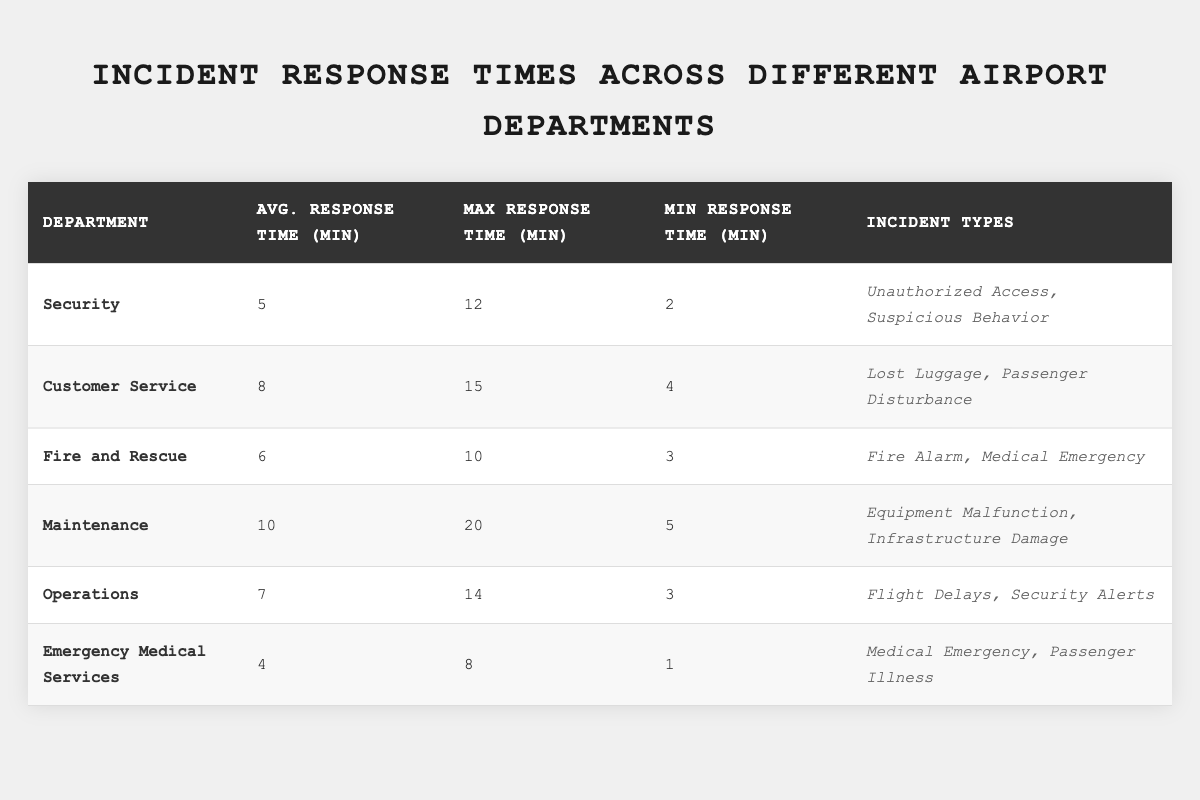What is the average response time for the Security department? The table shows that the average response time for the Security department is listed as 5 minutes.
Answer: 5 minutes Which department has the maximum response time? By examining the "Max Response Time" column, we see that the Maintenance department has the highest maximum response time of 20 minutes.
Answer: Maintenance What is the minimum response time for Emergency Medical Services? In the table, under "Min Response Time," Emergency Medical Services is shown to have a minimum response time of 1 minute.
Answer: 1 minute Calculate the average response time of all departments combined. To find this, sum the average response times of all departments: (5 + 8 + 6 + 10 + 7 + 4) = 40 minutes for 6 departments. Dividing gives us 40/6 = 6.67 minutes.
Answer: 6.67 minutes Is the average response time for the Fire and Rescue department less than 7 minutes? The table shows that Fire and Rescue has an average response time of 6 minutes, which is indeed less than 7 minutes.
Answer: Yes How many departments have an average response time greater than 7 minutes? From the table, the departments with average response times greater than 7 minutes are Customer Service (8), Maintenance (10). Operations with 7 minutes is not greater. Thus, there are 2 departments.
Answer: 2 departments Which department responds the fastest on average? By looking at the "Average Response Time" column, it is clear that Emergency Medical Services has the fastest average response time of 4 minutes.
Answer: Emergency Medical Services If the average response time for Customer Service increases by 5 minutes, what will be the new average? The current average for Customer Service is 8 minutes. Adding 5 minutes gives a new average of 8 + 5 = 13 minutes.
Answer: 13 minutes Are there any departments that have an average response time less than 5 minutes? Reviewing the averages, the only department with an average less than 5 minutes is Emergency Medical Services with an average of 4 minutes.
Answer: Yes What is the range of response times for the Operations department? The range is calculated by subtracting the minimum response time from the maximum response time: 14 (max) - 3 (min) = 11 minutes.
Answer: 11 minutes 